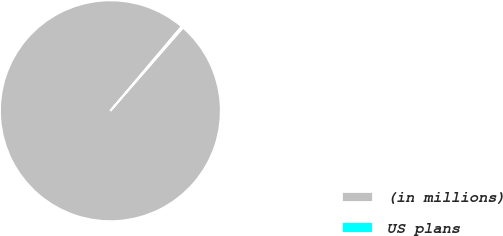Convert chart to OTSL. <chart><loc_0><loc_0><loc_500><loc_500><pie_chart><fcel>(in millions)<fcel>US plans<nl><fcel>99.75%<fcel>0.25%<nl></chart> 